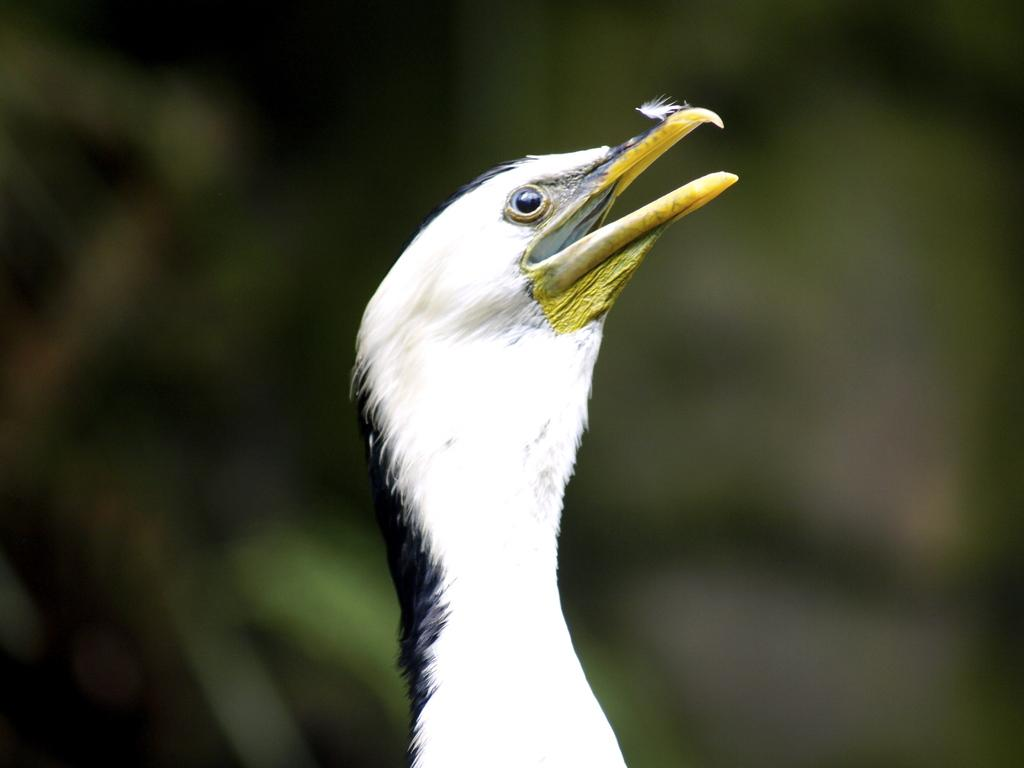What is the main subject in the foreground of the image? There is a bird in the foreground of the image. How would you describe the quality of the background in the image? The image is blurry in the background. What colors can be seen on the bird in the image? The bird has black, white, and yellow colors. What degree does the bird have in the image? There is no indication in the image that the bird has a degree, as birds do not attend educational institutions. 